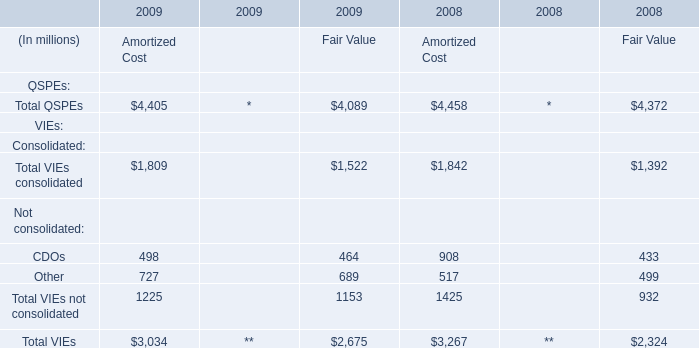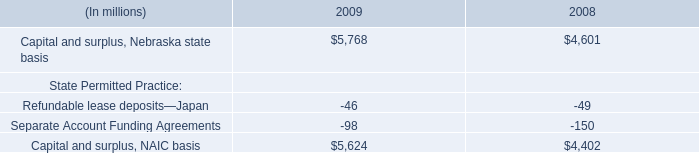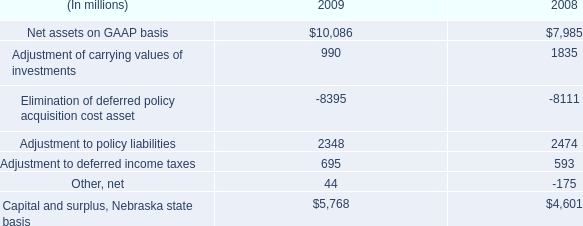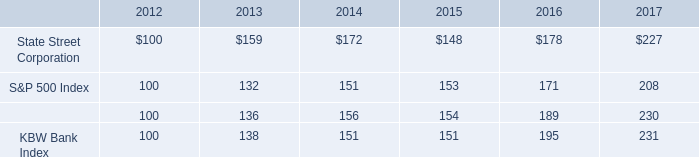what is the roi of an investment is state street corporation from 2012 to 2015? 
Computations: ((148 - 100) / 100)
Answer: 0.48. 